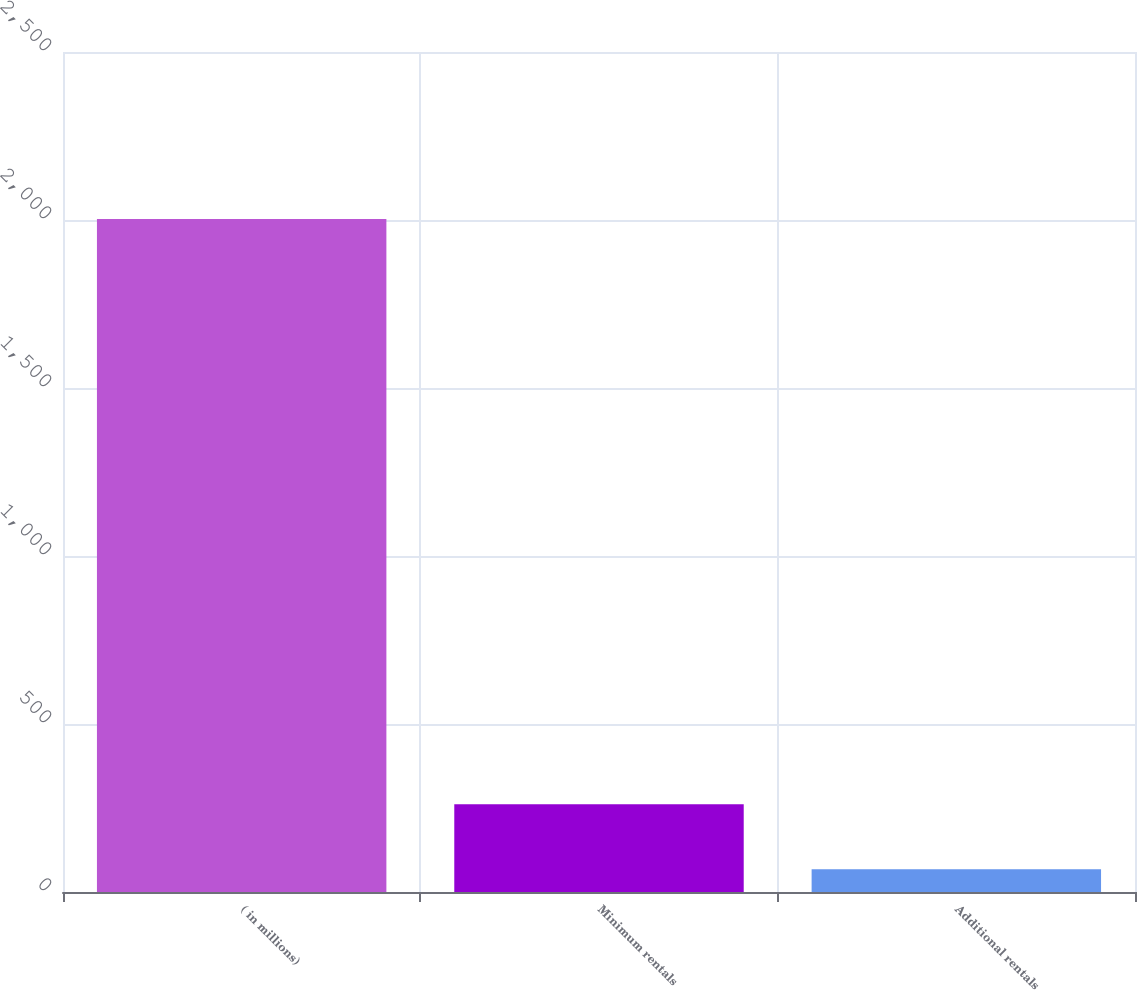Convert chart. <chart><loc_0><loc_0><loc_500><loc_500><bar_chart><fcel>( in millions)<fcel>Minimum rentals<fcel>Additional rentals<nl><fcel>2003<fcel>261.5<fcel>68<nl></chart> 